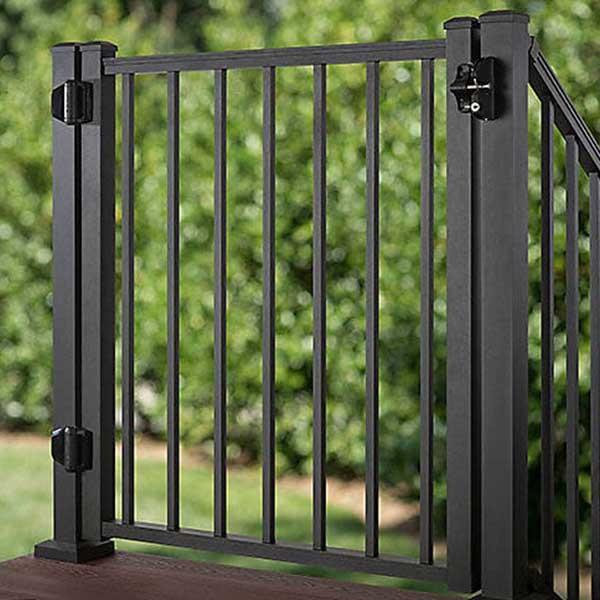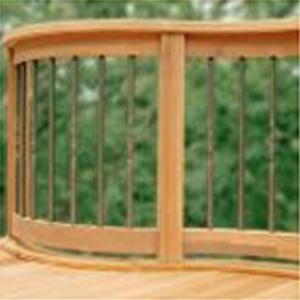The first image is the image on the left, the second image is the image on the right. Given the left and right images, does the statement "There are railings made of wood in each image" hold true? Answer yes or no. No. The first image is the image on the left, the second image is the image on the right. Assess this claim about the two images: "One image shows an all-black metal gate with hinges on the left and the latch on the right.". Correct or not? Answer yes or no. Yes. 